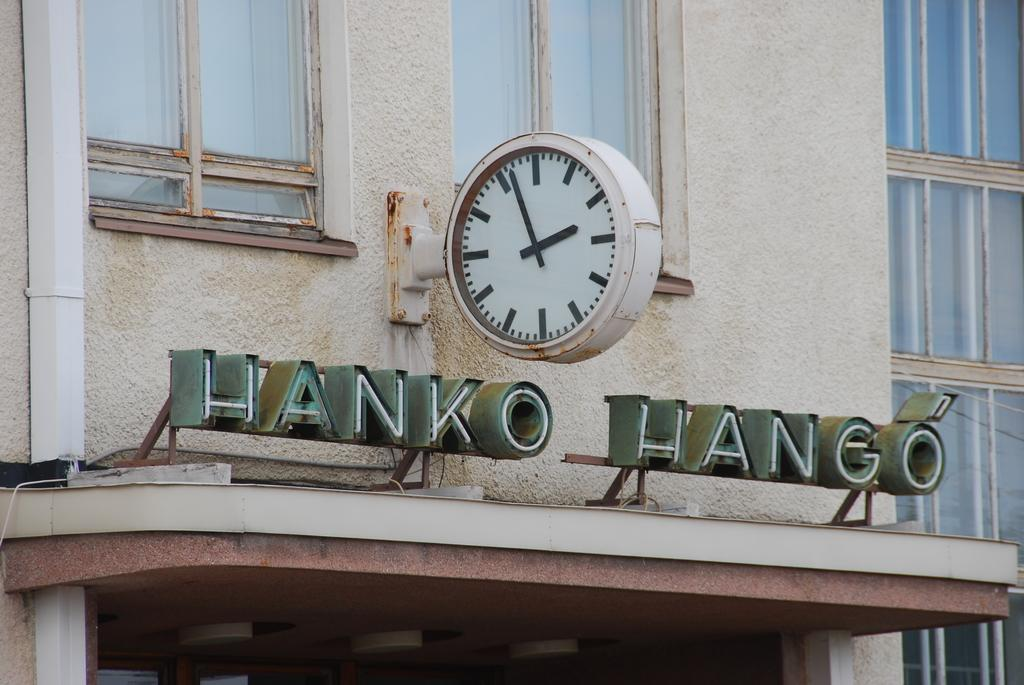Provide a one-sentence caption for the provided image. A clock hangs over a sign on a rusted, battered building reading Hanko Hango. 